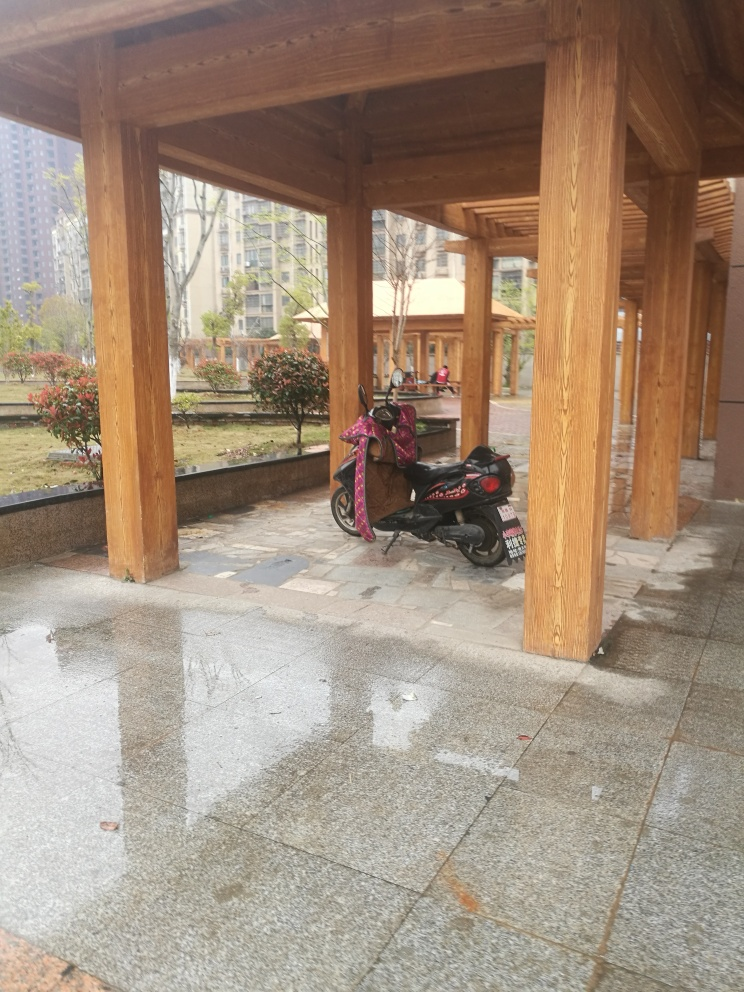Is the lighting bright in the image? The lighting in the photograph seems to be moderate rather than bright. There's adequate daylight to illuminate the scene clearly, displaying details such as the wooden pillars, the parked scooter, and the reflections on the wet ground. Shadow patterns indicate natural light filtering through a structure overhead, suggesting an overcast sky or a partially shaded area. 